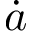Convert formula to latex. <formula><loc_0><loc_0><loc_500><loc_500>\dot { a }</formula> 